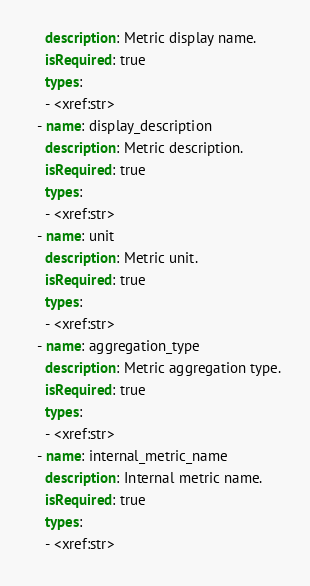Convert code to text. <code><loc_0><loc_0><loc_500><loc_500><_YAML_>    description: Metric display name.
    isRequired: true
    types:
    - <xref:str>
  - name: display_description
    description: Metric description.
    isRequired: true
    types:
    - <xref:str>
  - name: unit
    description: Metric unit.
    isRequired: true
    types:
    - <xref:str>
  - name: aggregation_type
    description: Metric aggregation type.
    isRequired: true
    types:
    - <xref:str>
  - name: internal_metric_name
    description: Internal metric name.
    isRequired: true
    types:
    - <xref:str>
</code> 